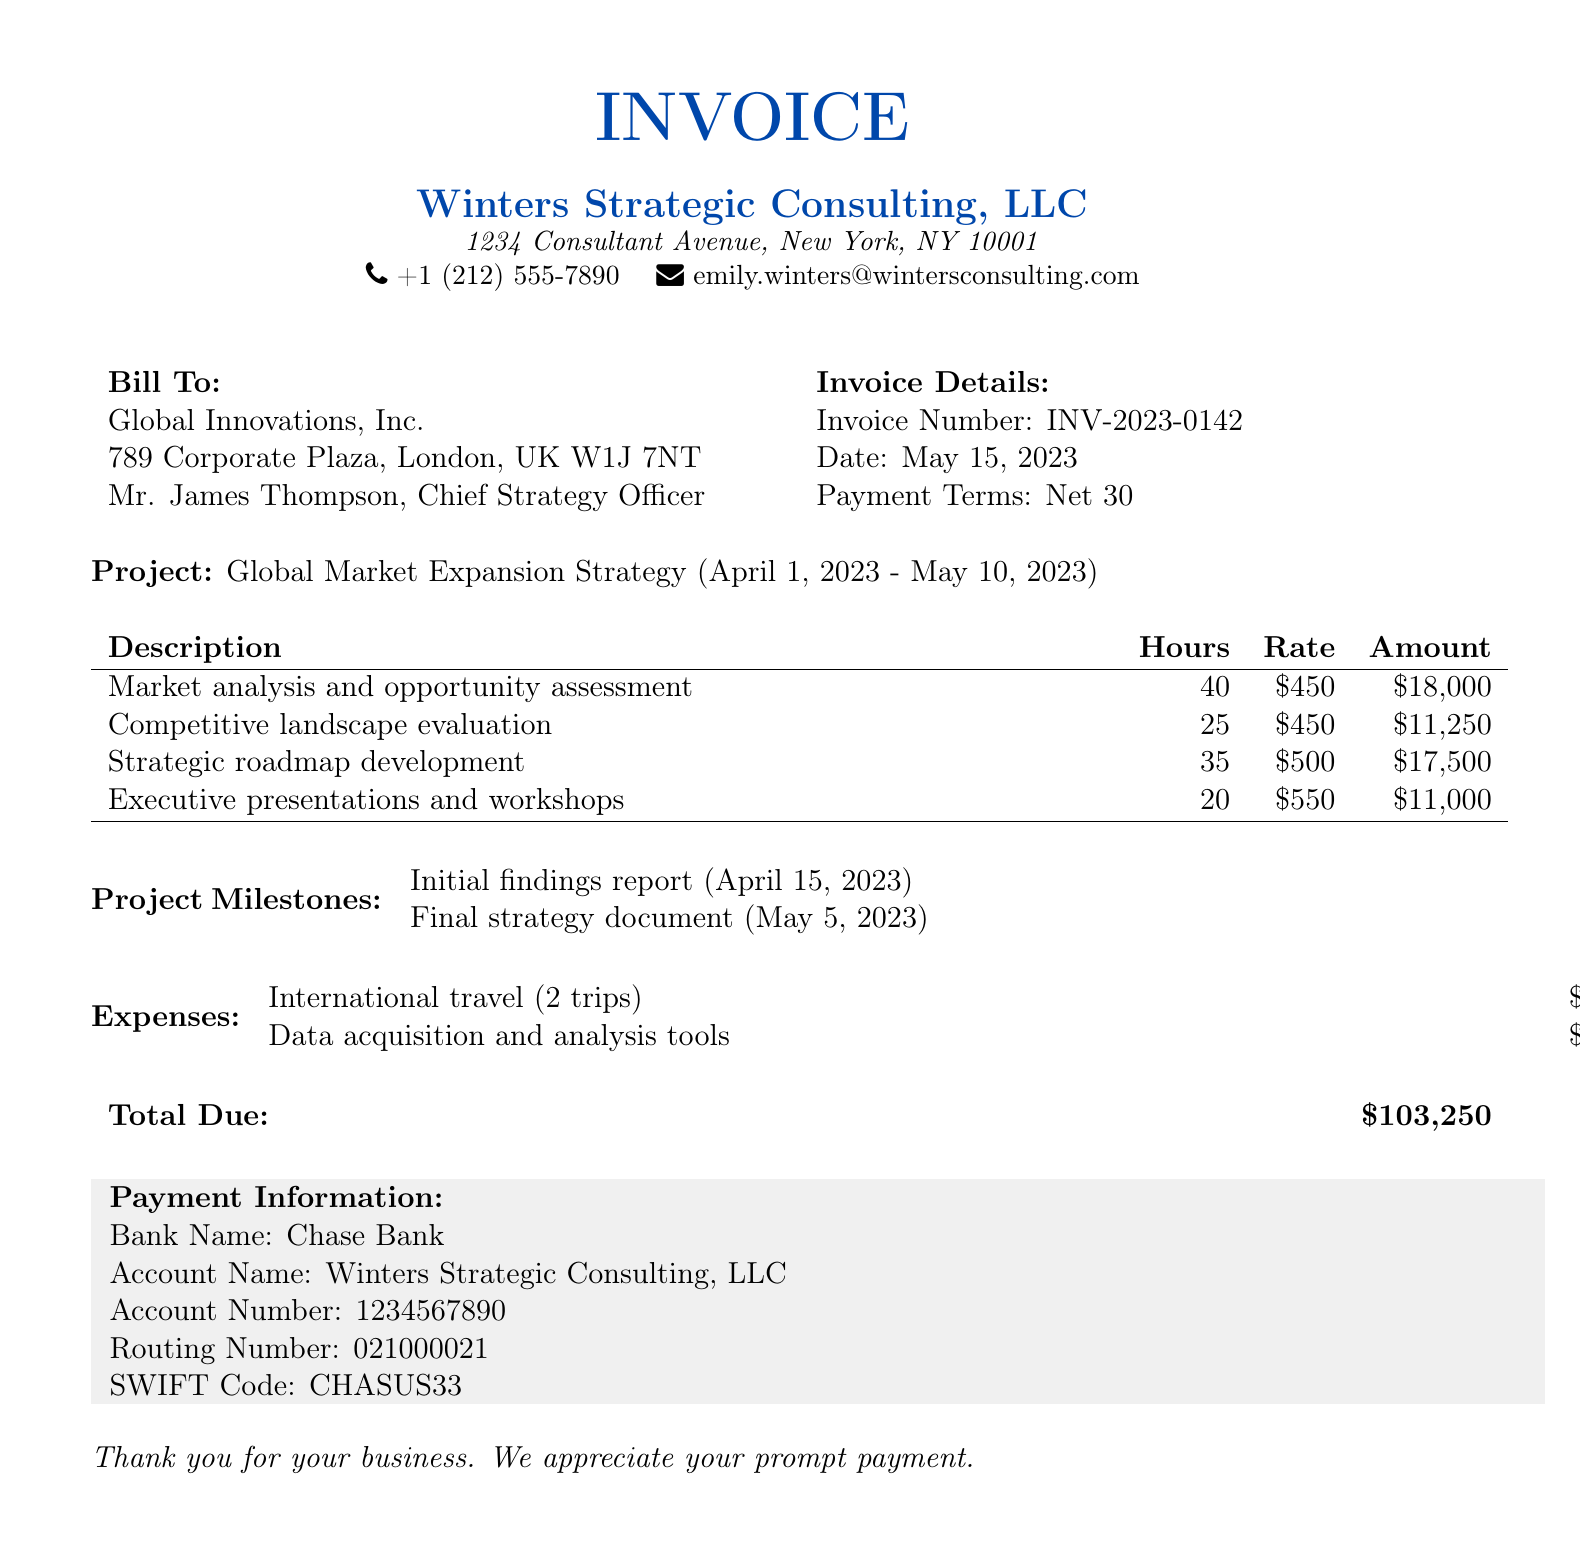What is the invoice number? The invoice number is listed in the invoice details section of the document.
Answer: INV-2023-0142 What is the date of the invoice? The date of the invoice is found in the invoice details section.
Answer: May 15, 2023 Who is the Chief Strategy Officer at Global Innovations, Inc.? The Chief Strategy Officer's name is provided in the bill to section.
Answer: Mr. James Thompson What is the total due amount? The total due amount is at the bottom of the invoice.
Answer: $103,250 How many hours were spent on market analysis and opportunity assessment? The hours spent on this task are listed in the services section of the document.
Answer: 40 What is the rate for strategic roadmap development? The rate for this service is indicated in the services table.
Answer: $500 What is the amount for the final strategy document milestone? The amount for the final strategy document is specified in the project milestones section.
Answer: $25,000 How many trips were made for international travel expenses? The number of trips is mentioned in the expenses section.
Answer: 2 What is the payment term specified in the invoice? The payment terms are clearly provided in the invoice details section.
Answer: Net 30 